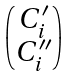Convert formula to latex. <formula><loc_0><loc_0><loc_500><loc_500>\begin{pmatrix} C _ { i } ^ { \prime } \\ C _ { i } ^ { \prime \prime } \end{pmatrix}</formula> 